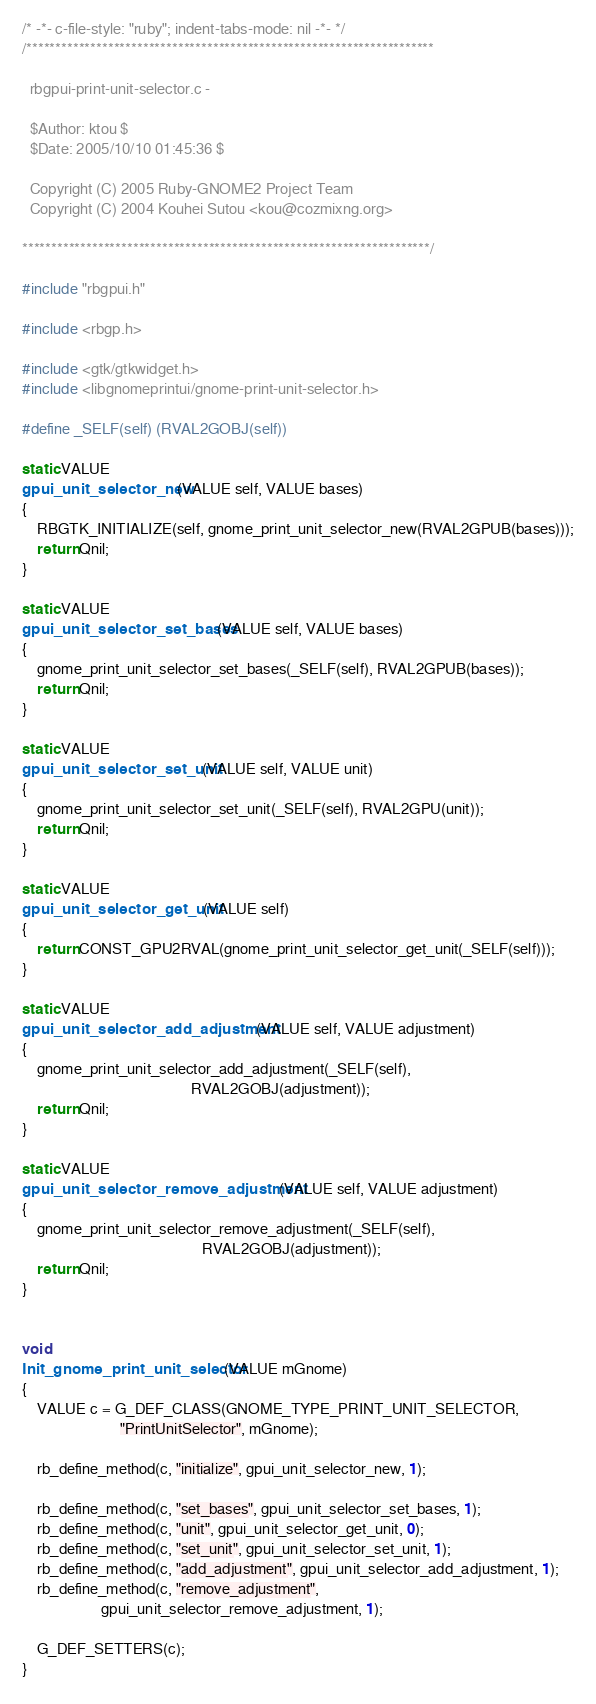Convert code to text. <code><loc_0><loc_0><loc_500><loc_500><_C_>/* -*- c-file-style: "ruby"; indent-tabs-mode: nil -*- */
/**********************************************************************

  rbgpui-print-unit-selector.c -

  $Author: ktou $
  $Date: 2005/10/10 01:45:36 $

  Copyright (C) 2005 Ruby-GNOME2 Project Team
  Copyright (C) 2004 Kouhei Sutou <kou@cozmixng.org>

**********************************************************************/

#include "rbgpui.h"

#include <rbgp.h>

#include <gtk/gtkwidget.h>
#include <libgnomeprintui/gnome-print-unit-selector.h>

#define _SELF(self) (RVAL2GOBJ(self))

static VALUE
gpui_unit_selector_new(VALUE self, VALUE bases)
{
    RBGTK_INITIALIZE(self, gnome_print_unit_selector_new(RVAL2GPUB(bases)));
    return Qnil;
}

static VALUE
gpui_unit_selector_set_bases(VALUE self, VALUE bases)
{
    gnome_print_unit_selector_set_bases(_SELF(self), RVAL2GPUB(bases));
    return Qnil;
}

static VALUE
gpui_unit_selector_set_unit(VALUE self, VALUE unit)
{
    gnome_print_unit_selector_set_unit(_SELF(self), RVAL2GPU(unit));
    return Qnil;
}

static VALUE
gpui_unit_selector_get_unit(VALUE self)
{
    return CONST_GPU2RVAL(gnome_print_unit_selector_get_unit(_SELF(self)));
}

static VALUE
gpui_unit_selector_add_adjustment(VALUE self, VALUE adjustment)
{
    gnome_print_unit_selector_add_adjustment(_SELF(self),
                                             RVAL2GOBJ(adjustment));
    return Qnil;
}

static VALUE
gpui_unit_selector_remove_adjustment(VALUE self, VALUE adjustment)
{
    gnome_print_unit_selector_remove_adjustment(_SELF(self),
                                                RVAL2GOBJ(adjustment));
    return Qnil;
}


void
Init_gnome_print_unit_selector(VALUE mGnome)
{
    VALUE c = G_DEF_CLASS(GNOME_TYPE_PRINT_UNIT_SELECTOR,
                          "PrintUnitSelector", mGnome);

    rb_define_method(c, "initialize", gpui_unit_selector_new, 1);

    rb_define_method(c, "set_bases", gpui_unit_selector_set_bases, 1);
    rb_define_method(c, "unit", gpui_unit_selector_get_unit, 0);
    rb_define_method(c, "set_unit", gpui_unit_selector_set_unit, 1);
    rb_define_method(c, "add_adjustment", gpui_unit_selector_add_adjustment, 1);
    rb_define_method(c, "remove_adjustment",
                     gpui_unit_selector_remove_adjustment, 1);

    G_DEF_SETTERS(c);
}
</code> 